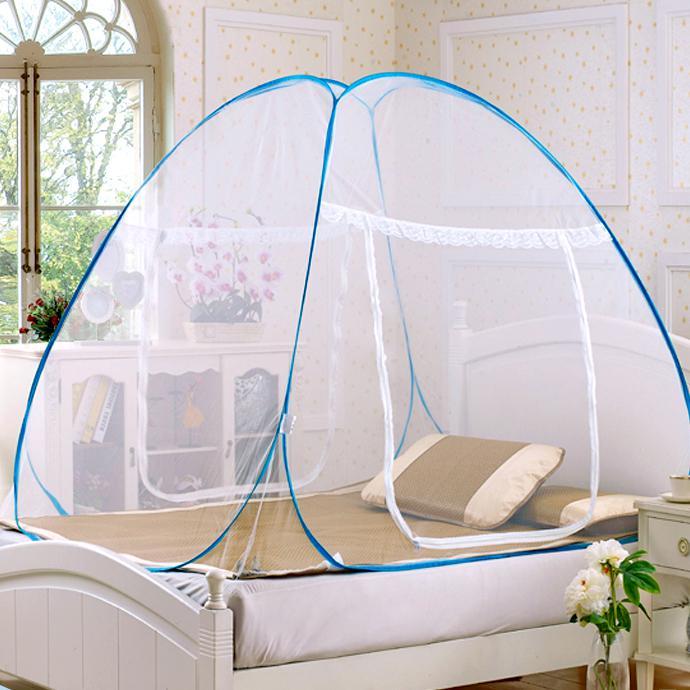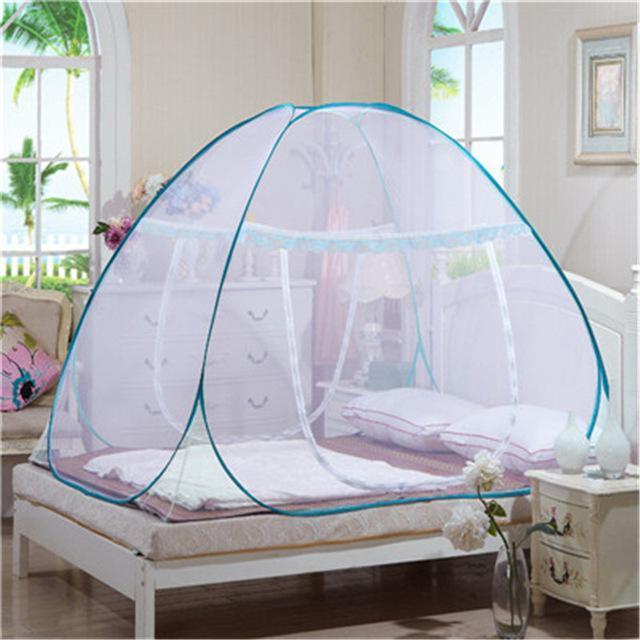The first image is the image on the left, the second image is the image on the right. Analyze the images presented: Is the assertion "The left and right image contains the same number of canopies one circle and one square." valid? Answer yes or no. No. The first image is the image on the left, the second image is the image on the right. Considering the images on both sides, is "There is exactly one round canopy." valid? Answer yes or no. No. 